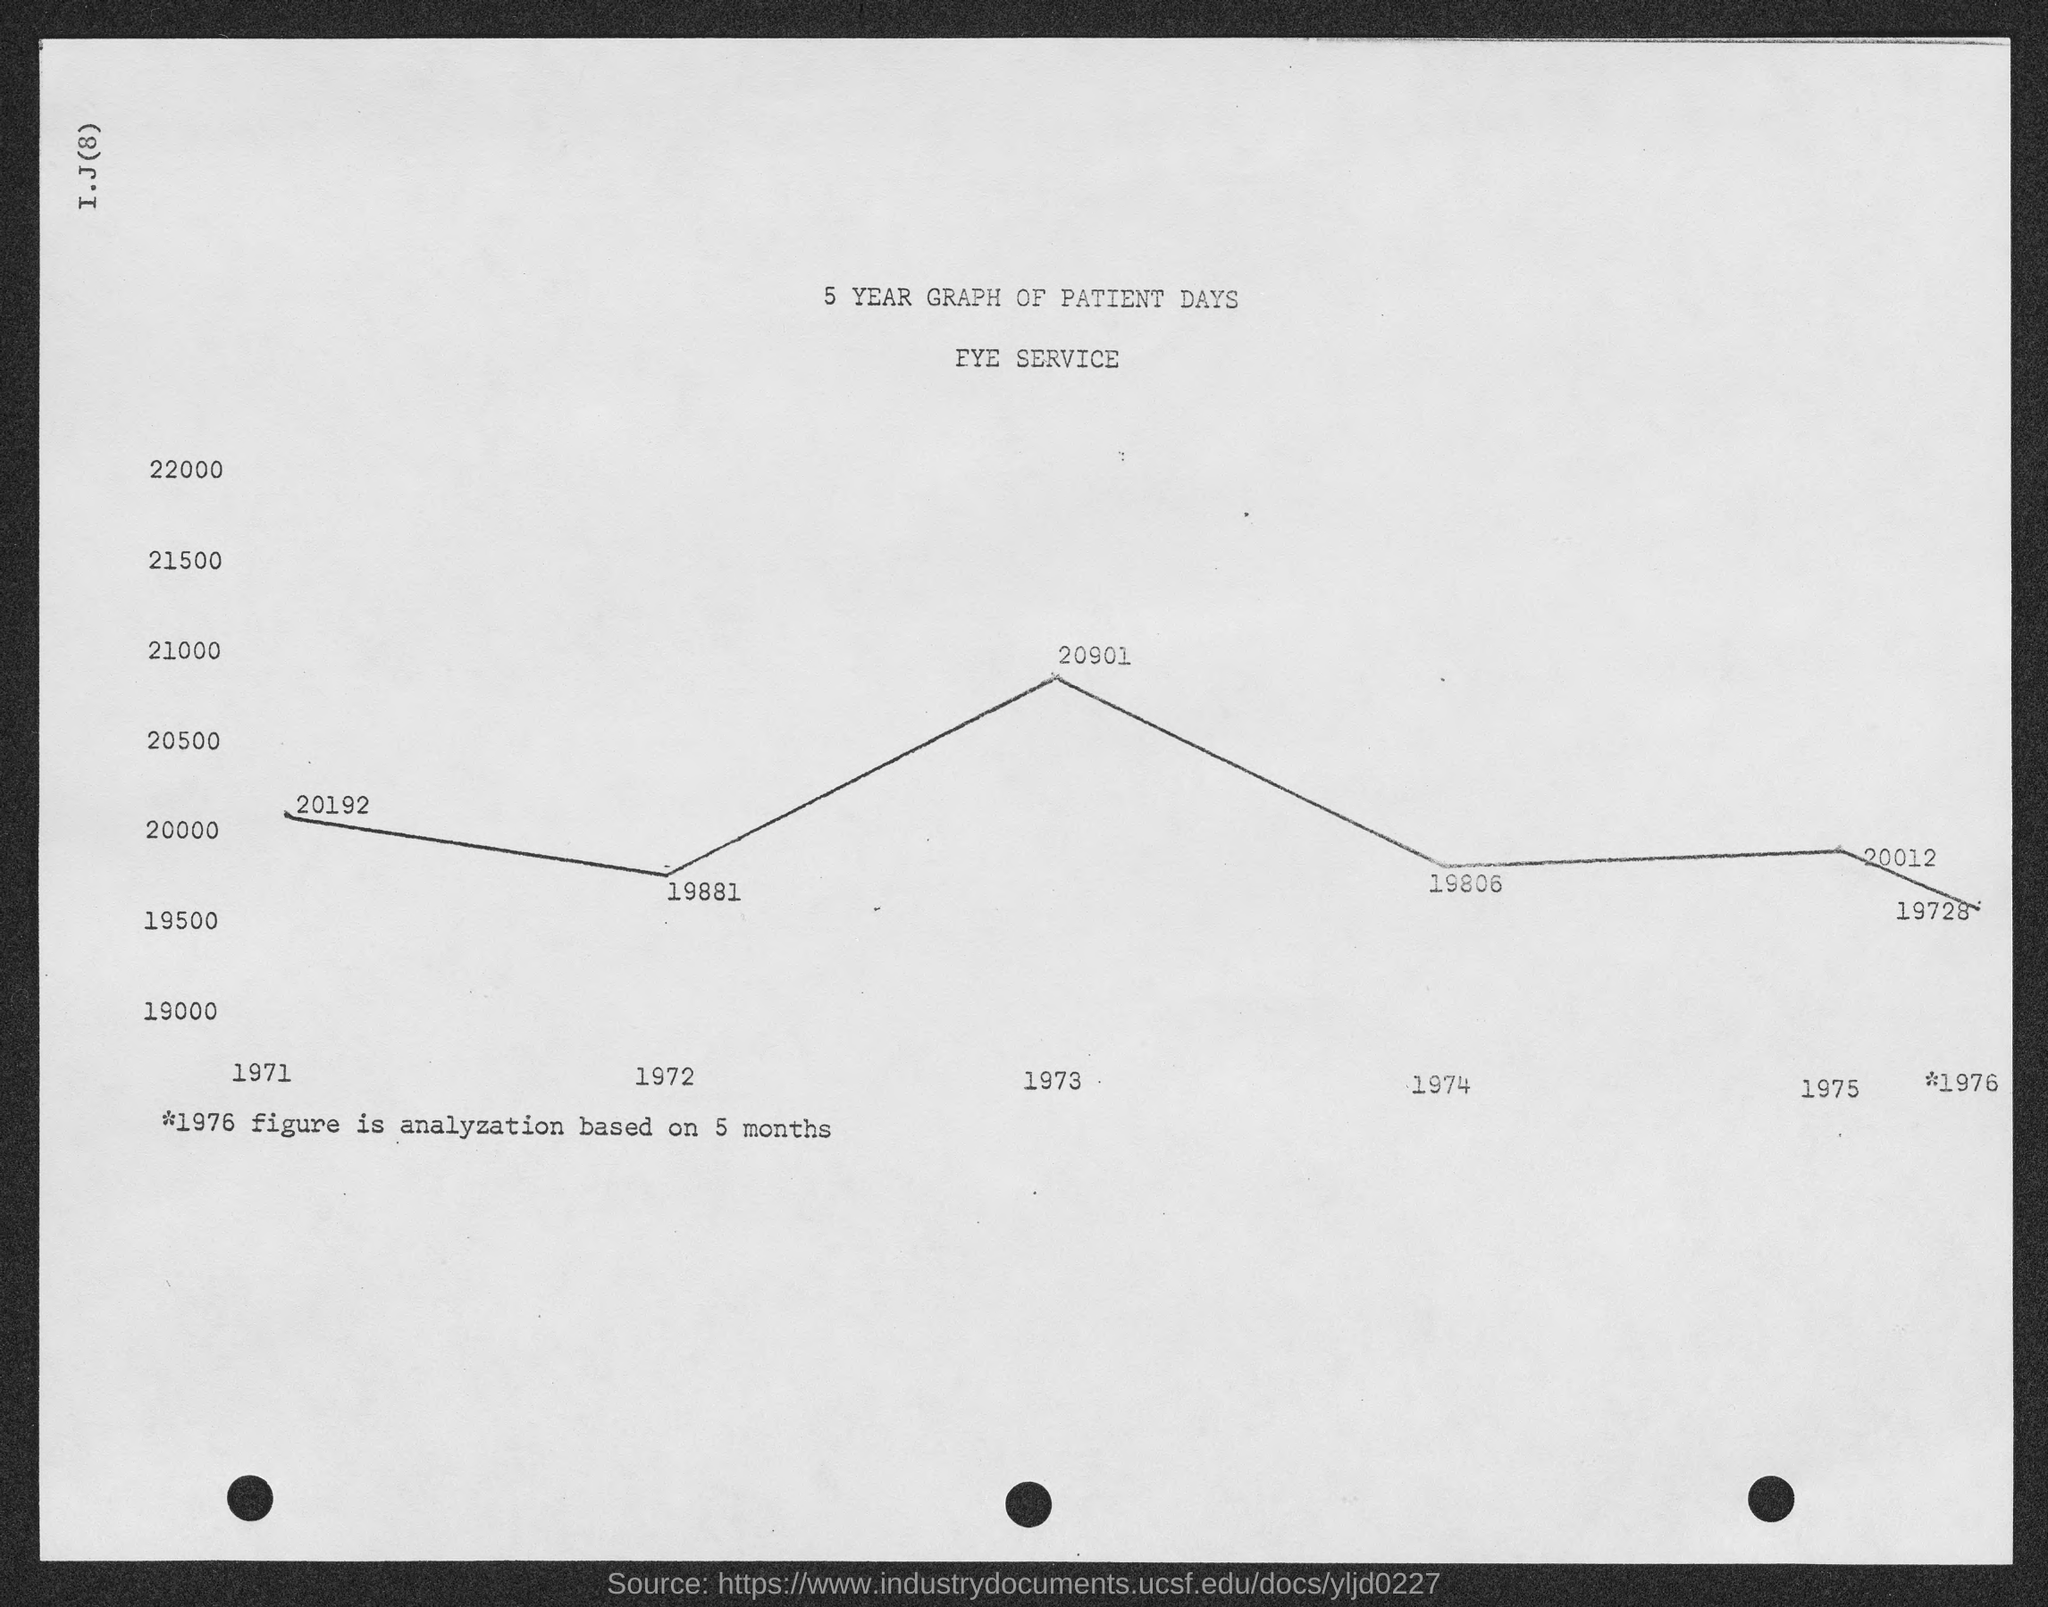Indicate a few pertinent items in this graphic. The name of the service mentioned in the given page is the Eye Service. The value of the given form in the year 1973 is 20901. The heading on the given page is "5-Year Graph of Patient Days. In the year 1972, the value mentioned in the given form was 19881. In the given form, the value is mentioned as "19806" for the year 1974. 